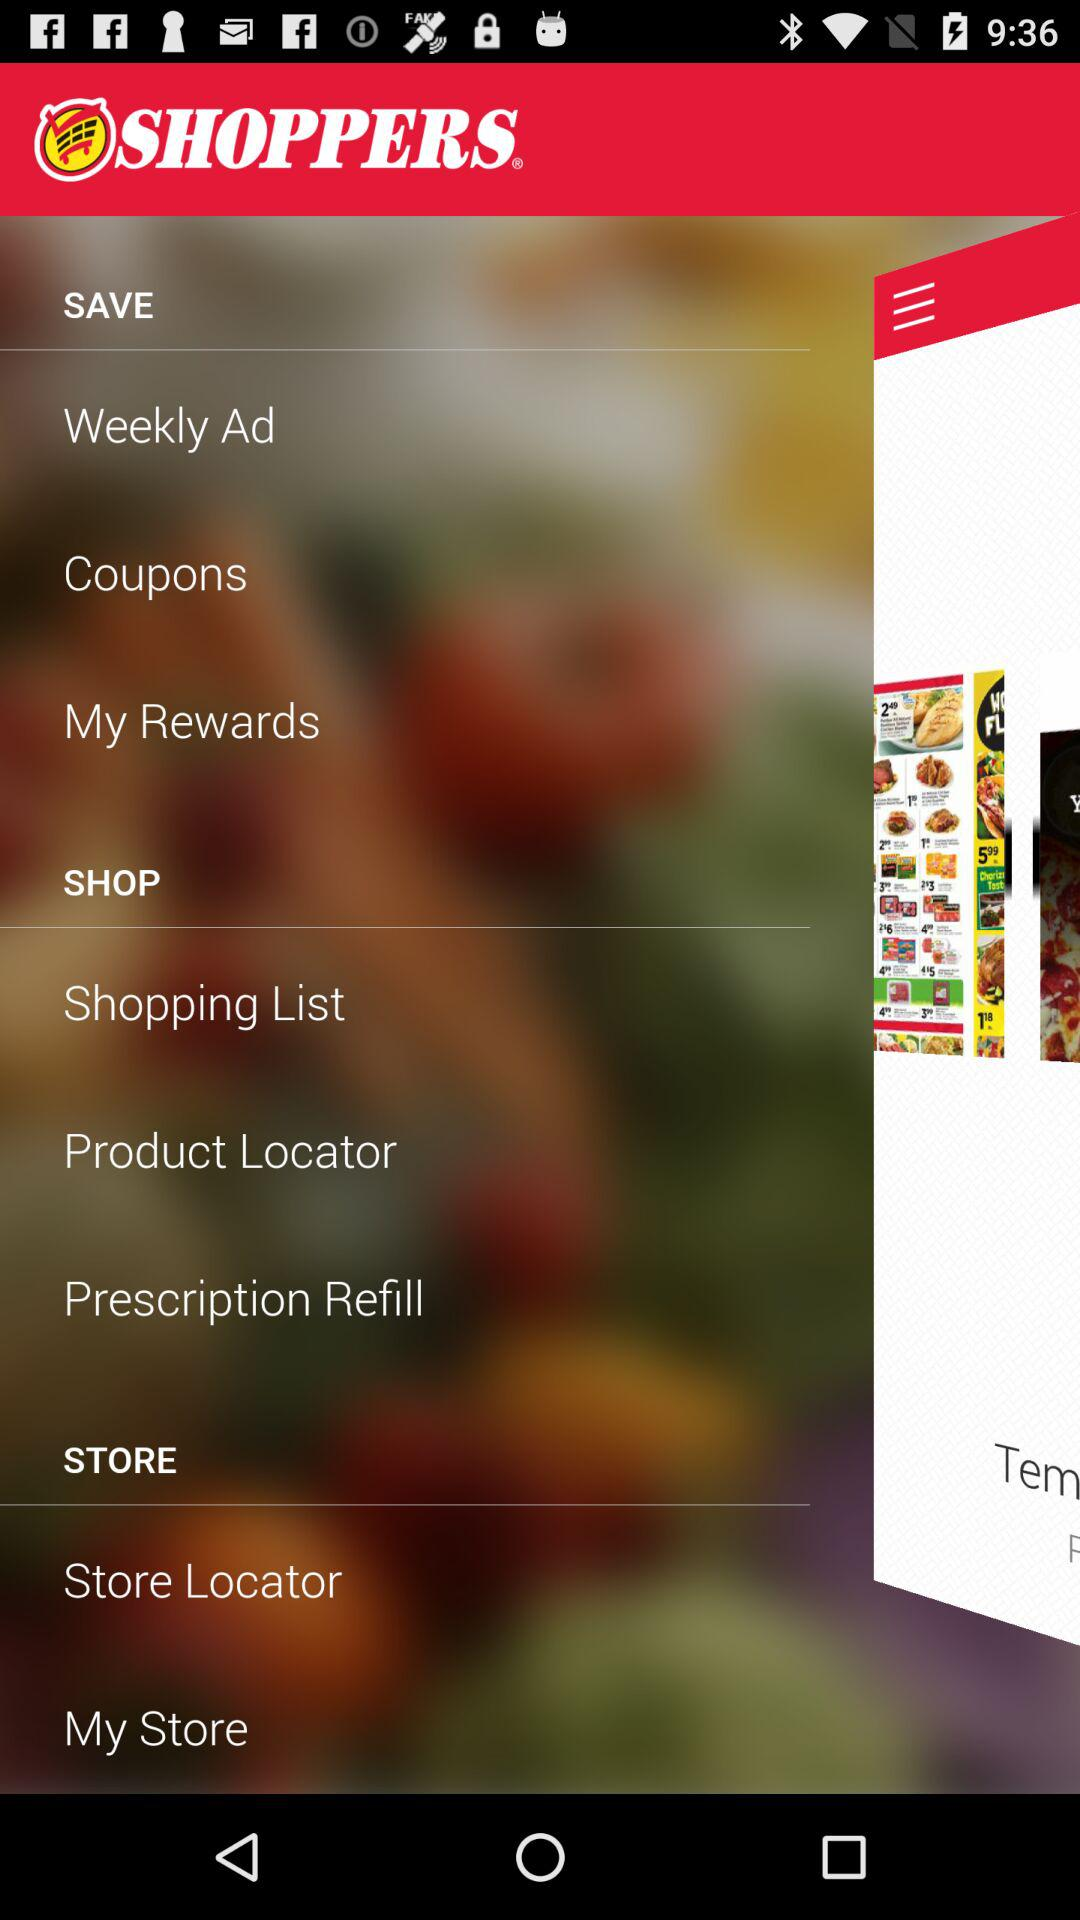What is the app name? The app name is "SHOPPERS". 